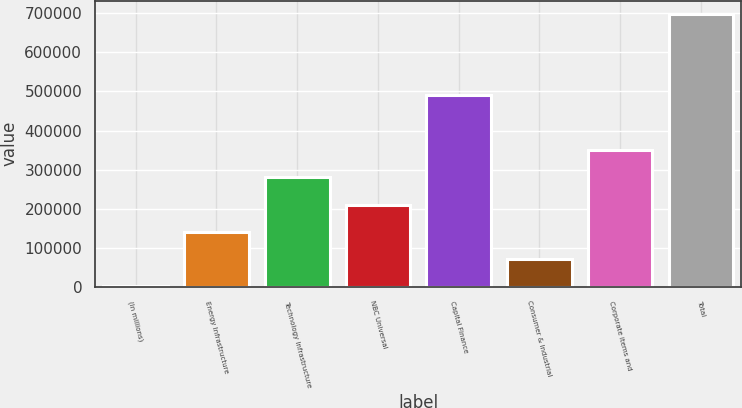Convert chart. <chart><loc_0><loc_0><loc_500><loc_500><bar_chart><fcel>(In millions)<fcel>Energy Infrastructure<fcel>Technology Infrastructure<fcel>NBC Universal<fcel>Capital Finance<fcel>Consumer & Industrial<fcel>Corporate items and<fcel>Total<nl><fcel>2006<fcel>141059<fcel>280113<fcel>210586<fcel>491000<fcel>71532.7<fcel>349640<fcel>697273<nl></chart> 